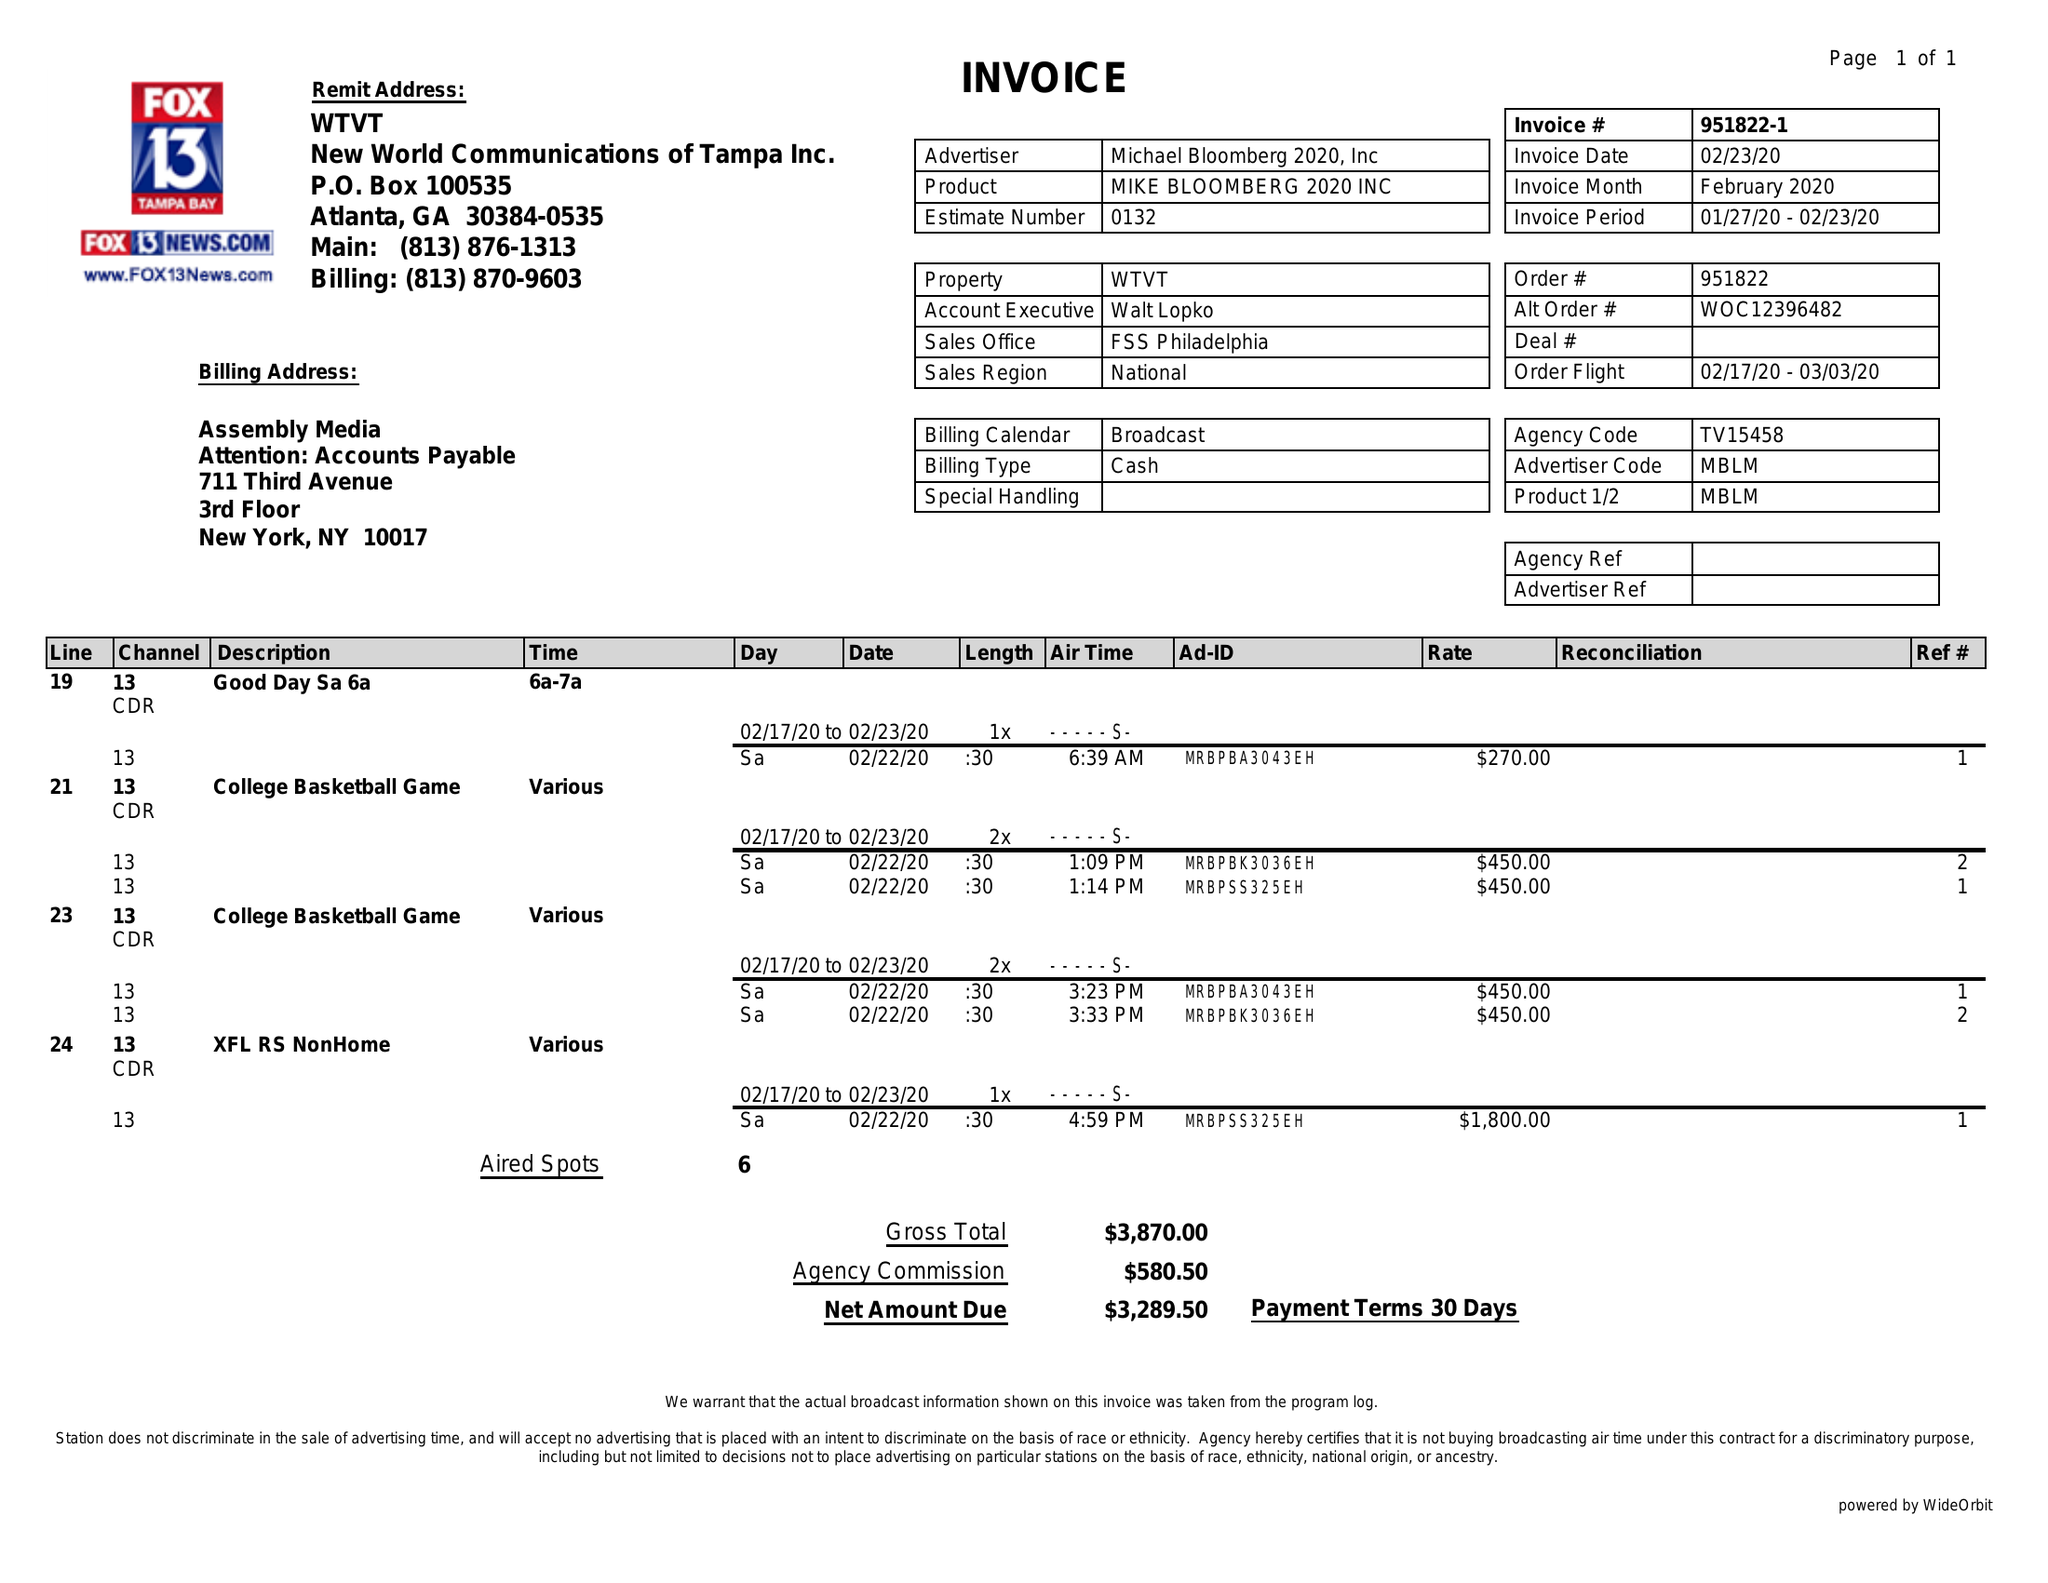What is the value for the gross_amount?
Answer the question using a single word or phrase. 3870.00 